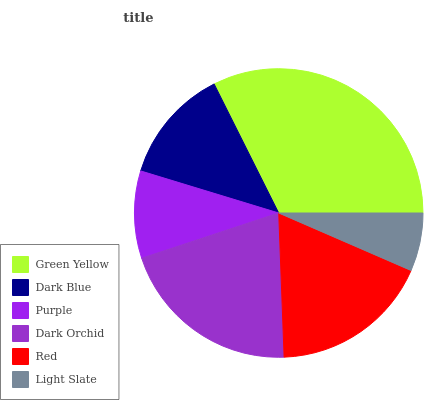Is Light Slate the minimum?
Answer yes or no. Yes. Is Green Yellow the maximum?
Answer yes or no. Yes. Is Dark Blue the minimum?
Answer yes or no. No. Is Dark Blue the maximum?
Answer yes or no. No. Is Green Yellow greater than Dark Blue?
Answer yes or no. Yes. Is Dark Blue less than Green Yellow?
Answer yes or no. Yes. Is Dark Blue greater than Green Yellow?
Answer yes or no. No. Is Green Yellow less than Dark Blue?
Answer yes or no. No. Is Red the high median?
Answer yes or no. Yes. Is Dark Blue the low median?
Answer yes or no. Yes. Is Dark Orchid the high median?
Answer yes or no. No. Is Dark Orchid the low median?
Answer yes or no. No. 